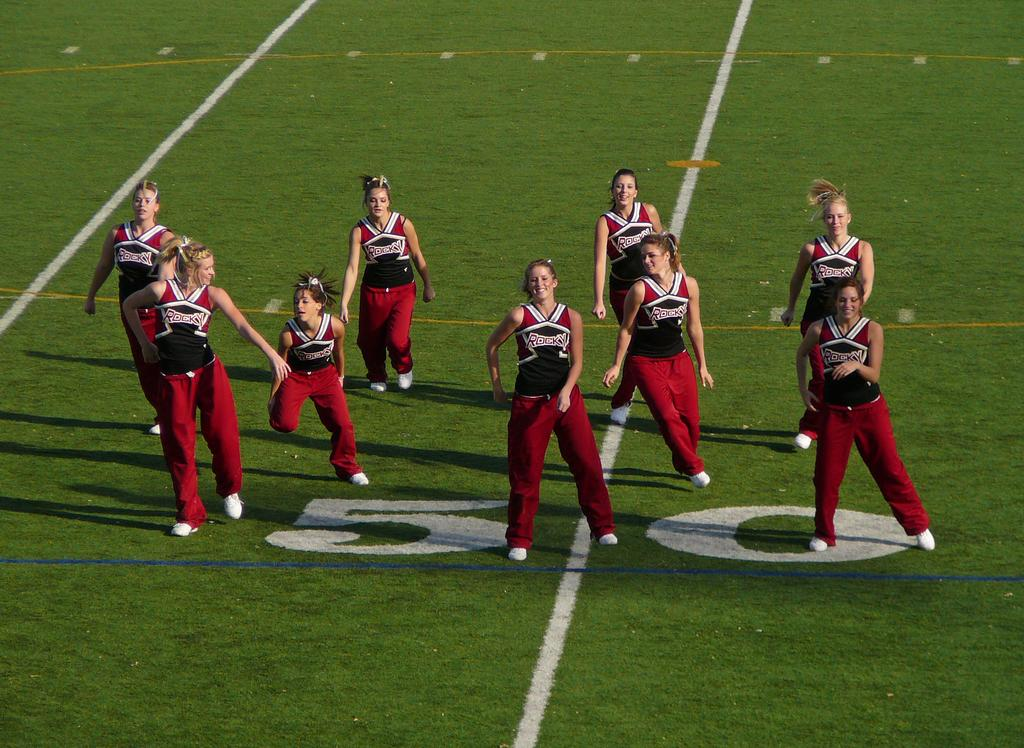What is the main subject of the image? The main subject of the image is a group of people. What are the people in the image doing? The people appear to be dancing. What type of surface is visible at the bottom of the image? There is ground visible at the bottom of the image. What type of peace symbol can be seen in the image? There is no peace symbol present in the image; it features a group of people dancing. What language is being spoken during the meeting in the image? There is no meeting depicted in the image, only a group of people dancing. 